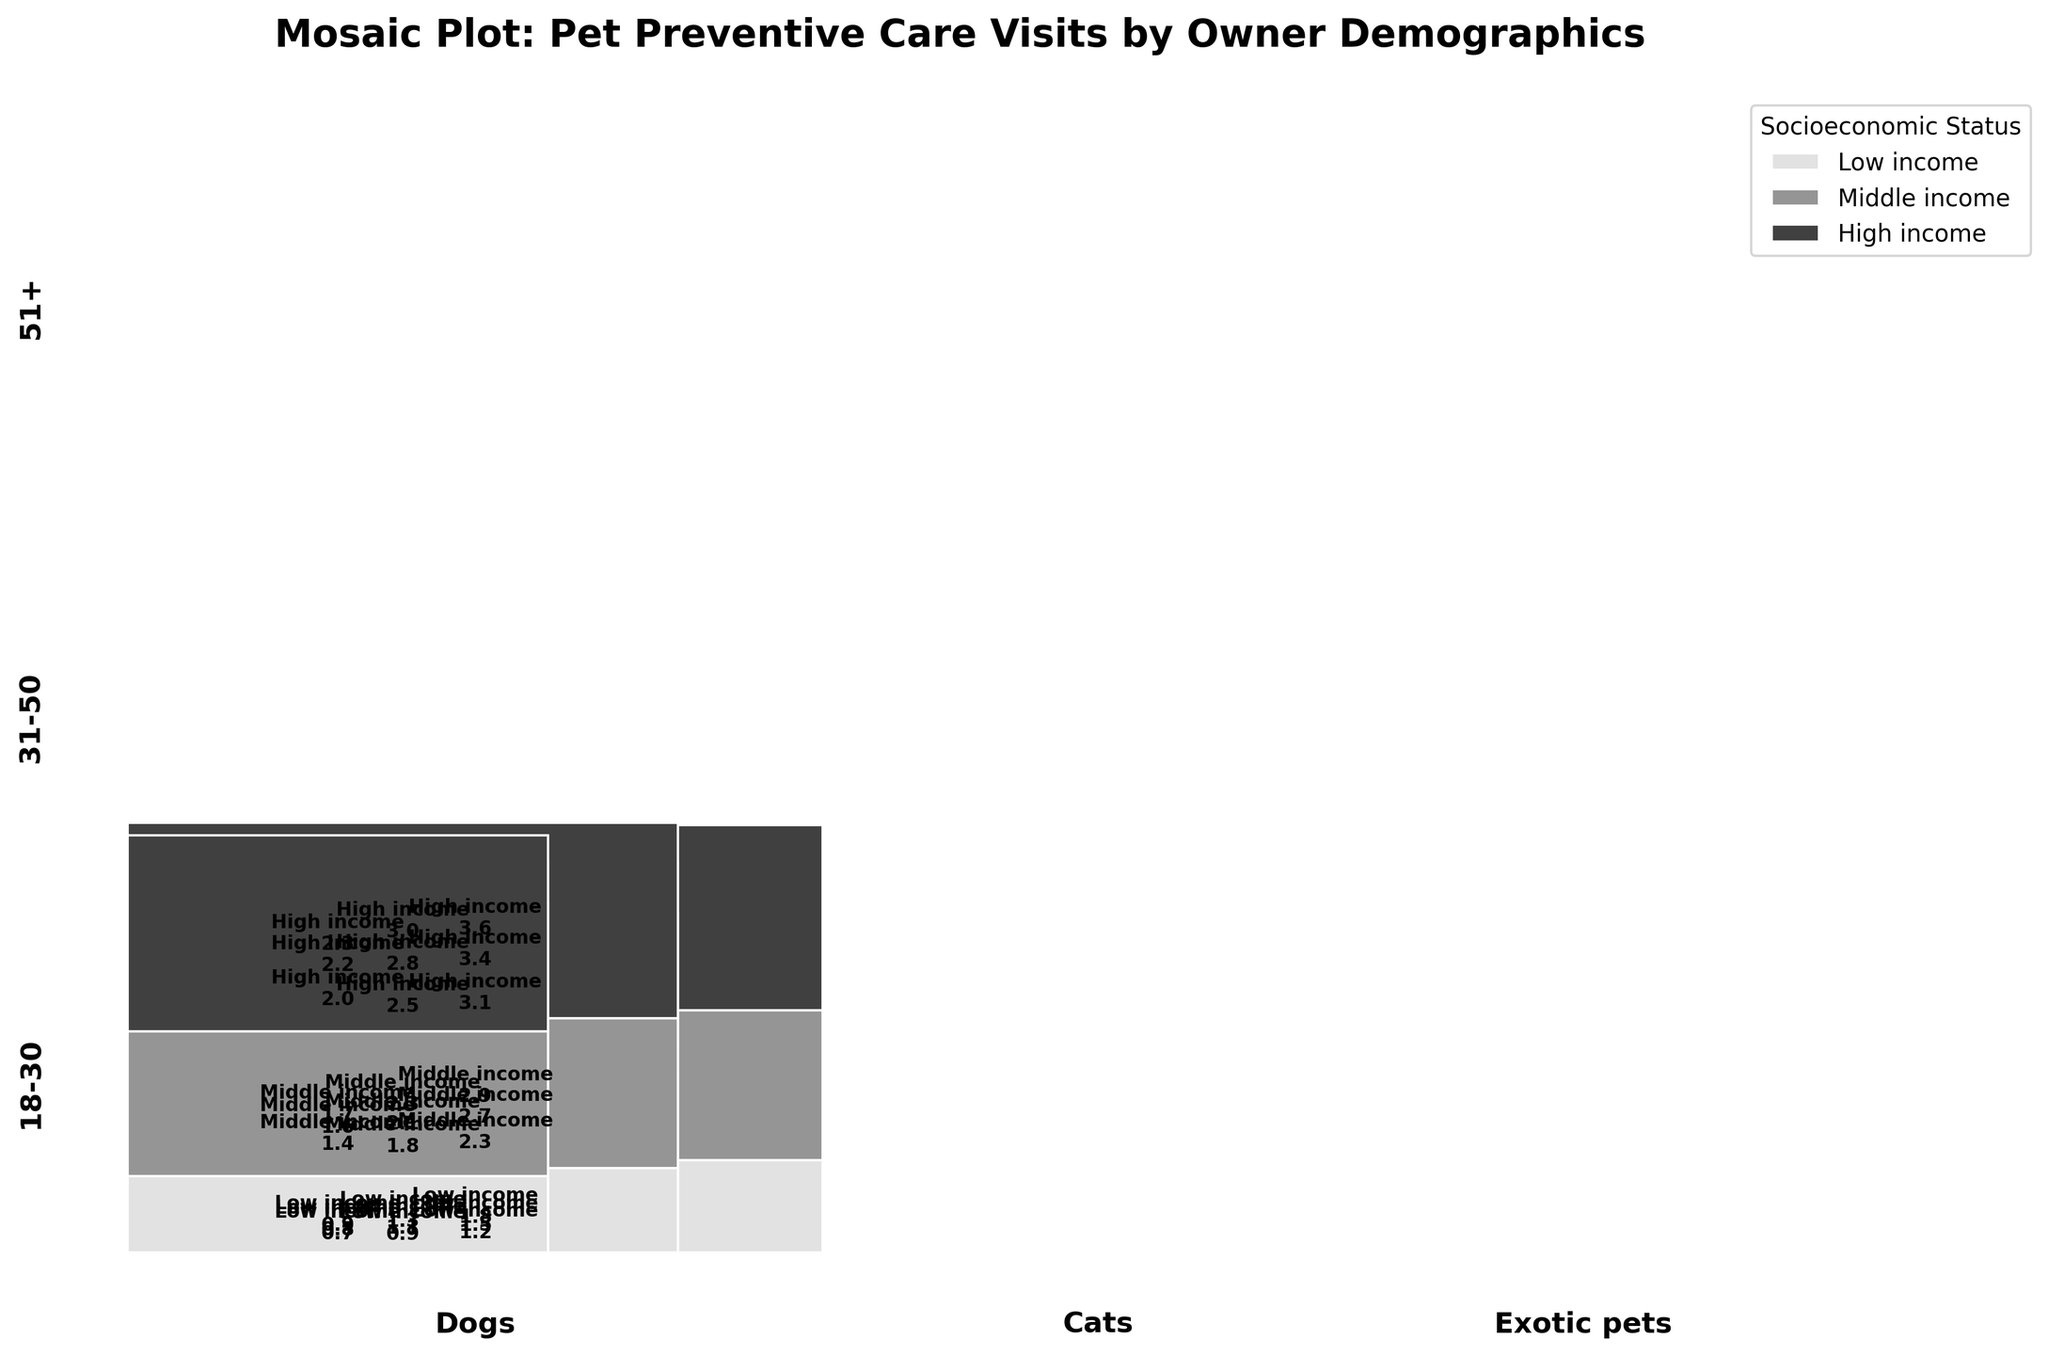What is the title of the mosaic plot? The title of the figure is displayed prominently at the top of the plot. You can read it directly from there.
Answer: Mosaic Plot: Pet Preventive Care Visits by Owner Demographics Which pet type has the most preventive care visits for owners aged 31-50 with high income? To answer this, locate the section corresponding to owners aged 31-50, high income, and then identify the pet type that occupies the largest area in this section. Dogs have the largest rectangle area within the 31-50 high-income group.
Answer: Dogs How do preventive care visits for exotic pets change across socioeconomic statuses for owners aged 18-30? Examine the section where exotic pets are represented for owners aged 18-30, and note the height of the rectangles corresponding to low, middle, and high-income statuses. Visits increase from 0.7 for low-income to 1.4 for middle-income, and 2.0 for high-income.
Answer: Increase Comparing high income owners aged 51+ for cats and dogs, which has more preventive care visits? Identify the section for high-income owners aged 51+, and compare the height or size of the rectangles representing cats and dogs in this section. The rectangle for dogs is larger, indicating more visits.
Answer: Dogs What is the general trend in preventive care visits across socioeconomic status within each pet type? Observe the change in the height of rectangles within each pet type as you move from low to middle to high socioeconomic status. Generally, the height increases, indicating more visits with higher socioeconomic status.
Answer: Increases What is the socioeconomic status with the highest number of preventive care visits for cats owned by people ages 18-30? Assess the section for cats owned by people aged 18-30, and find which of the three (low, middle, high income) has the tallest rectangle. High-income has the highest number of visits.
Answer: High income How do preventive care visits for dogs differ between owners aged 18-30 and owners aged 51+, considering middle income? Compare the rectangles for middle-income owners of dogs in the 18-30 and 51+ age groups. The rectangle for the 51+ group is taller, indicating more visits.
Answer: More visits for owners aged 51+ Which age group has the most preventive care visits for exotic pets overall and why? Sum the areas of the rectangles for each age group within the exotic pets section. The 51+ group has the largest combined area of rectangles, indicating the highest number of visits overall.
Answer: 51+ What are the preventive care visits for cats owned by people aged 31-50 with middle income? Locate the rectangle corresponding to cats, owners aged 31-50, and middle income, and read the number displayed within it or deduce it from its size. The value is 2.1 visits.
Answer: 2.1 How does socioeconomic status impact preventive visits for dogs owned by people aged 18-30? Compare the heights of the rectangles for dogs within the 18-30 age group from low to high income. The visits increase as socioeconomic status increases, from 1.2 to 3.1.
Answer: Increases 